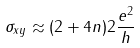<formula> <loc_0><loc_0><loc_500><loc_500>\sigma _ { x y } \approx ( 2 + 4 n ) 2 \frac { e ^ { 2 } } { h }</formula> 